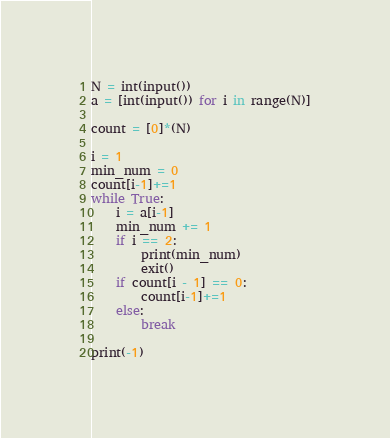Convert code to text. <code><loc_0><loc_0><loc_500><loc_500><_Python_>N = int(input())
a = [int(input()) for i in range(N)]

count = [0]*(N)

i = 1
min_num = 0
count[i-1]+=1
while True:
    i = a[i-1]
    min_num += 1
    if i == 2:
        print(min_num)
        exit()
    if count[i - 1] == 0:
        count[i-1]+=1
    else:
        break

print(-1)</code> 